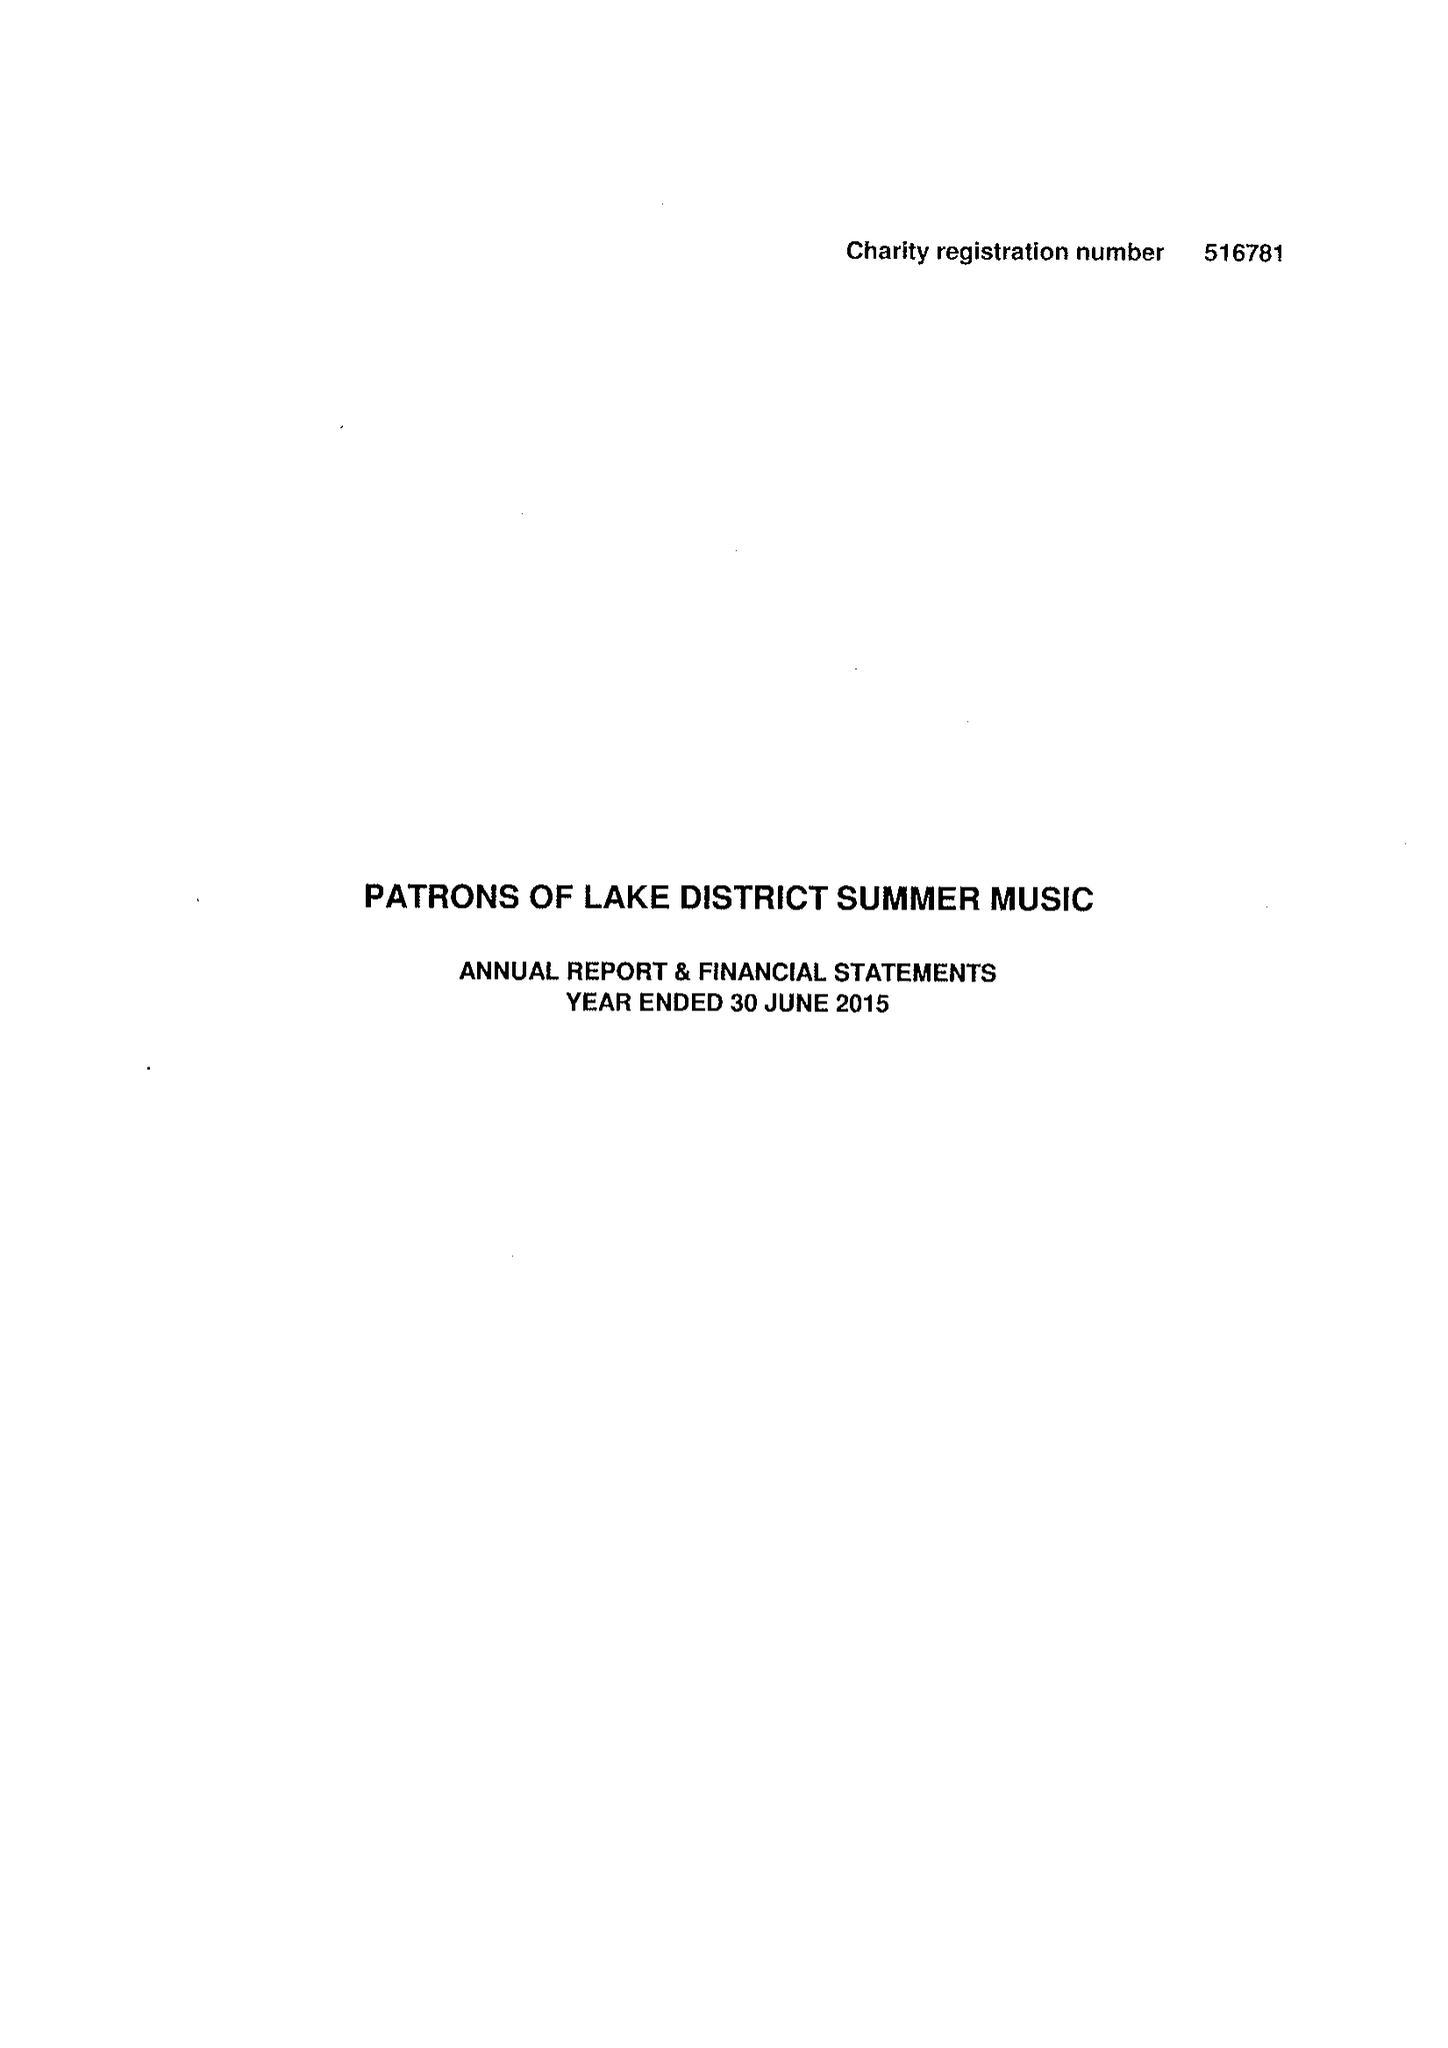What is the value for the income_annually_in_british_pounds?
Answer the question using a single word or phrase. 28621.00 